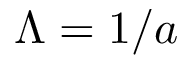Convert formula to latex. <formula><loc_0><loc_0><loc_500><loc_500>\Lambda = 1 / a</formula> 